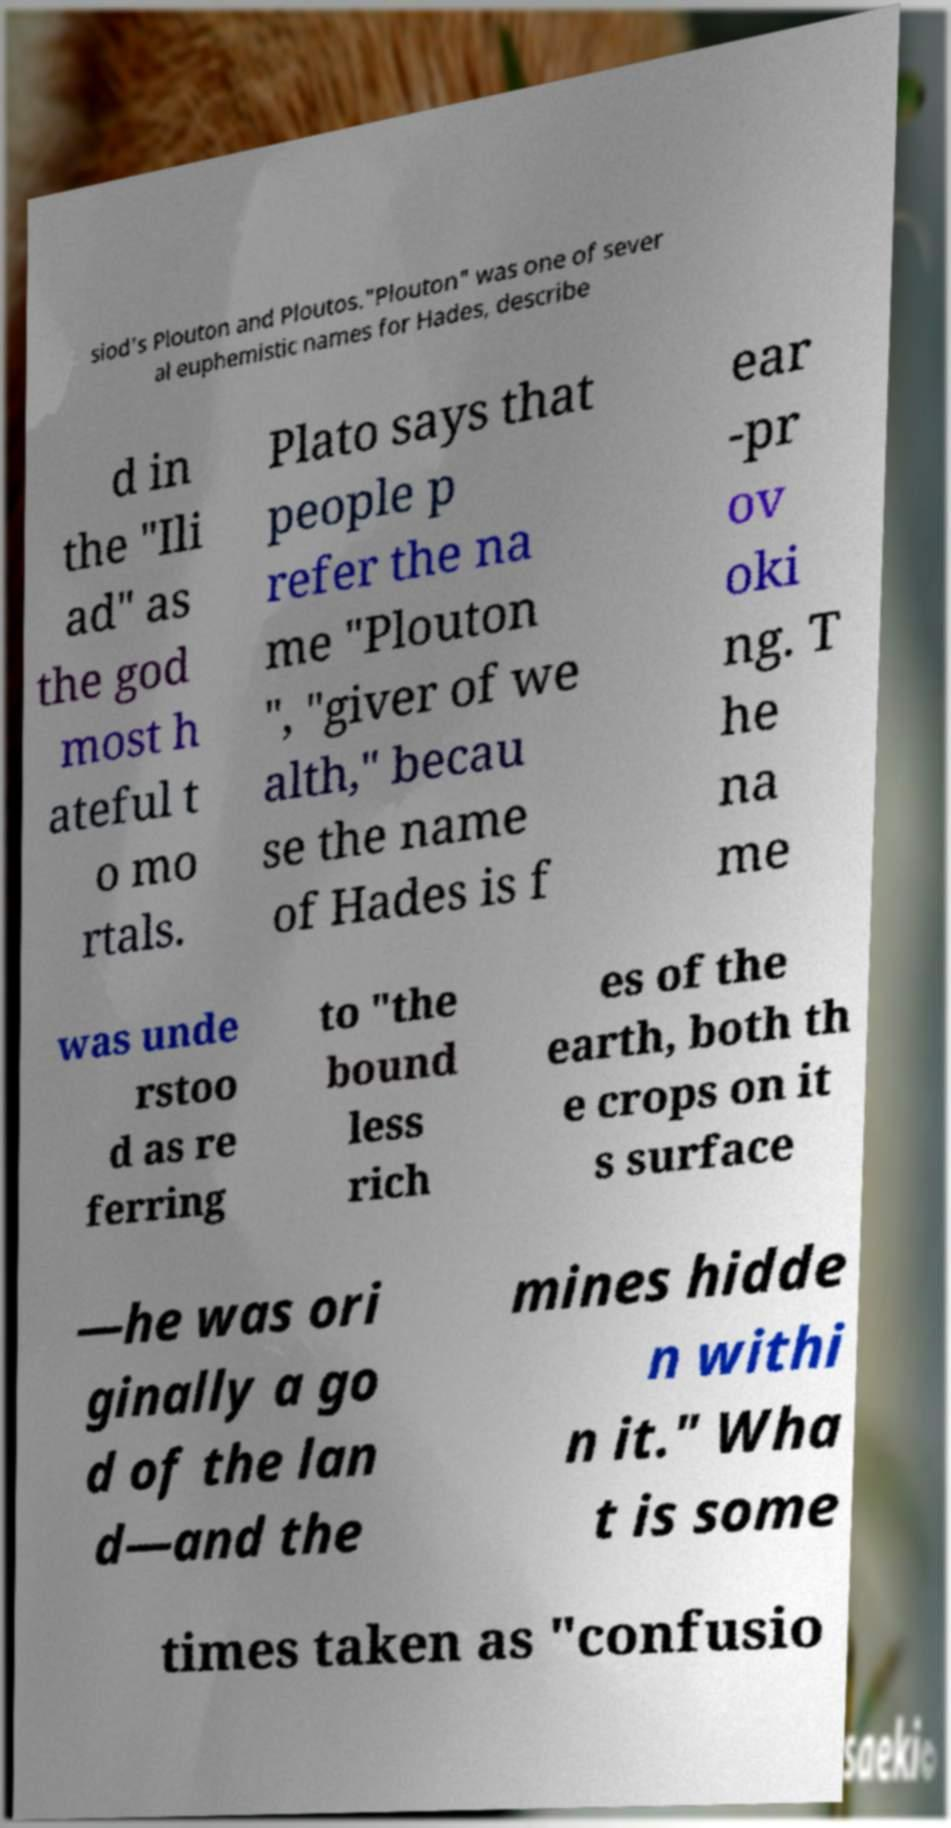Can you accurately transcribe the text from the provided image for me? siod's Plouton and Ploutos."Plouton" was one of sever al euphemistic names for Hades, describe d in the "Ili ad" as the god most h ateful t o mo rtals. Plato says that people p refer the na me "Plouton ", "giver of we alth," becau se the name of Hades is f ear -pr ov oki ng. T he na me was unde rstoo d as re ferring to "the bound less rich es of the earth, both th e crops on it s surface —he was ori ginally a go d of the lan d—and the mines hidde n withi n it." Wha t is some times taken as "confusio 